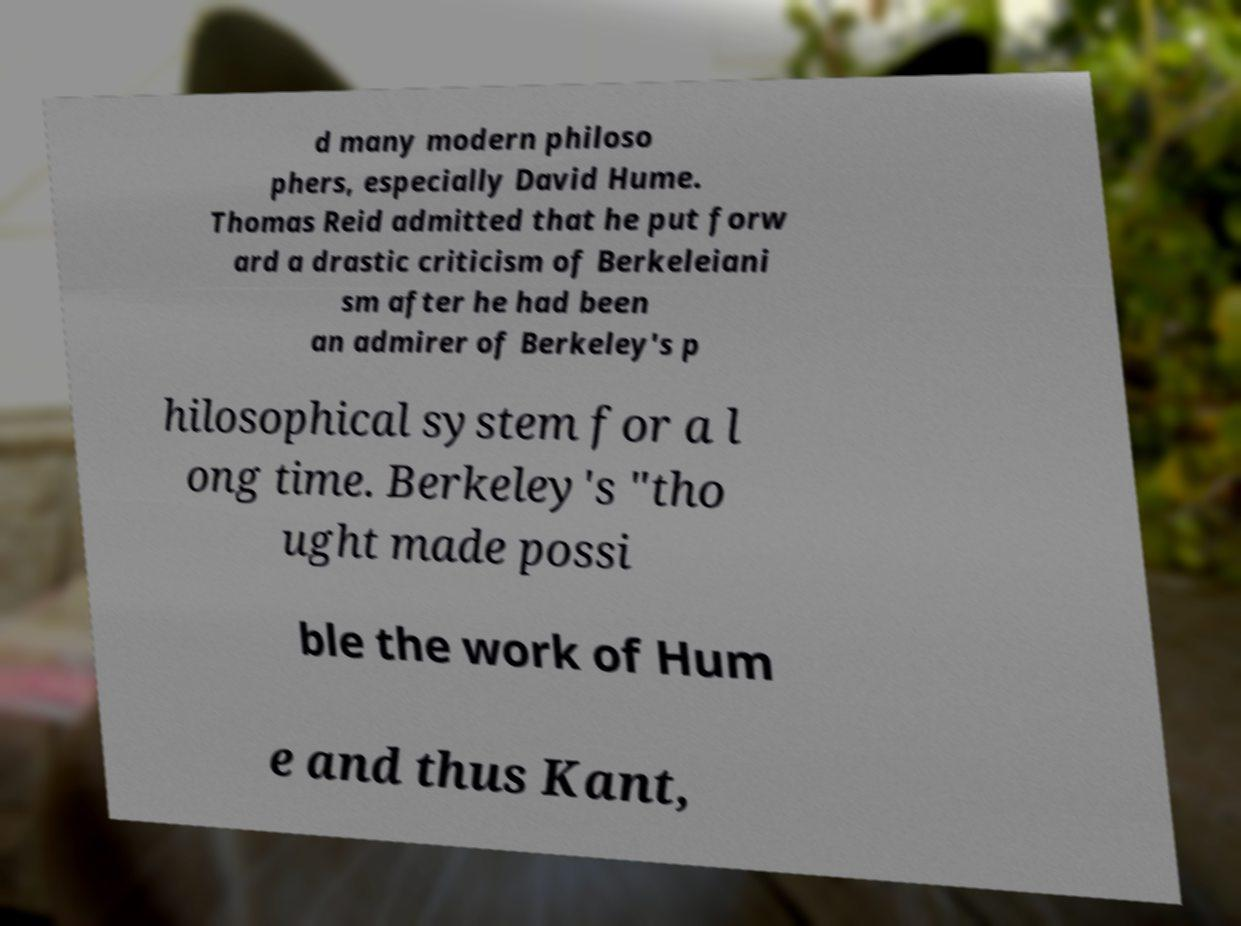Can you accurately transcribe the text from the provided image for me? d many modern philoso phers, especially David Hume. Thomas Reid admitted that he put forw ard a drastic criticism of Berkeleiani sm after he had been an admirer of Berkeley's p hilosophical system for a l ong time. Berkeley's "tho ught made possi ble the work of Hum e and thus Kant, 